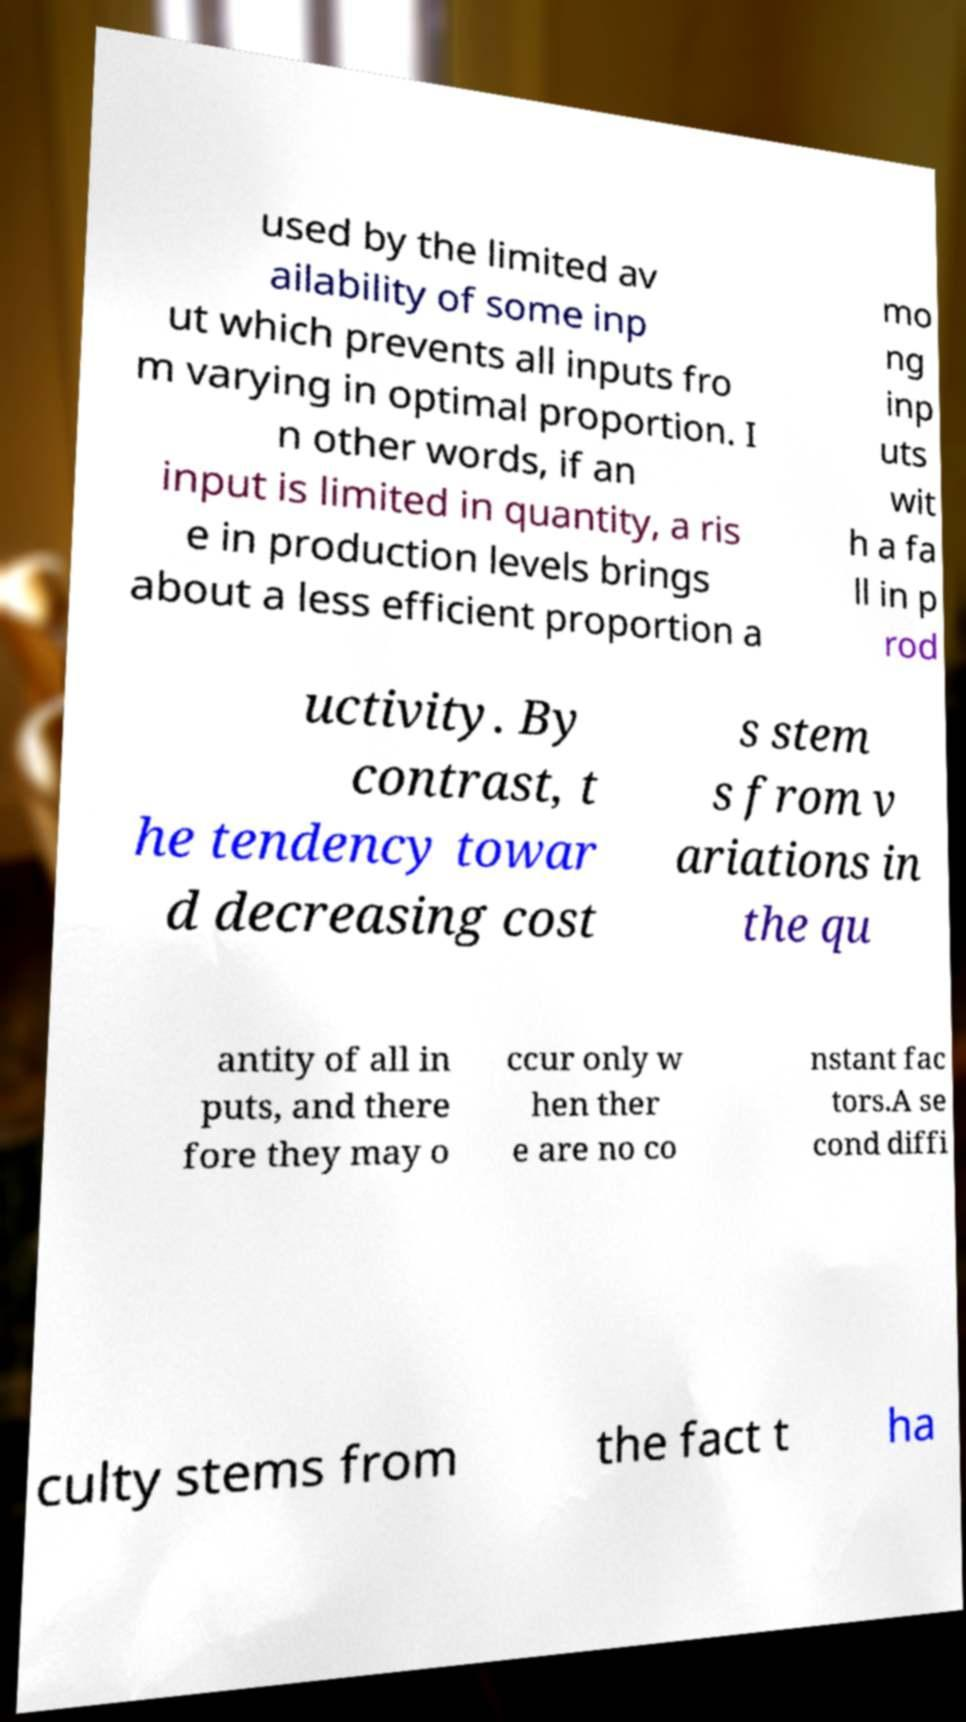I need the written content from this picture converted into text. Can you do that? used by the limited av ailability of some inp ut which prevents all inputs fro m varying in optimal proportion. I n other words, if an input is limited in quantity, a ris e in production levels brings about a less efficient proportion a mo ng inp uts wit h a fa ll in p rod uctivity. By contrast, t he tendency towar d decreasing cost s stem s from v ariations in the qu antity of all in puts, and there fore they may o ccur only w hen ther e are no co nstant fac tors.A se cond diffi culty stems from the fact t ha 